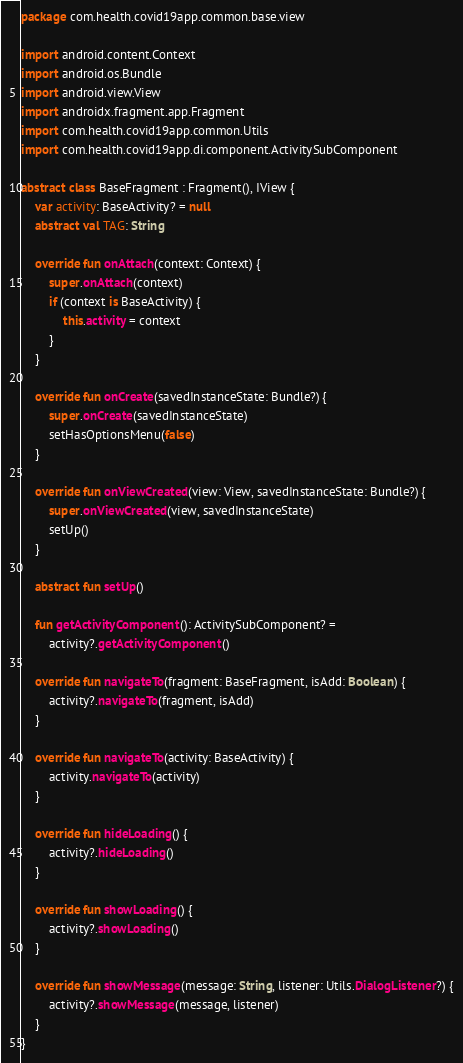Convert code to text. <code><loc_0><loc_0><loc_500><loc_500><_Kotlin_>package com.health.covid19app.common.base.view

import android.content.Context
import android.os.Bundle
import android.view.View
import androidx.fragment.app.Fragment
import com.health.covid19app.common.Utils
import com.health.covid19app.di.component.ActivitySubComponent

abstract class BaseFragment : Fragment(), IView {
    var activity: BaseActivity? = null
    abstract val TAG: String

    override fun onAttach(context: Context) {
        super.onAttach(context)
        if (context is BaseActivity) {
            this.activity = context
        }
    }

    override fun onCreate(savedInstanceState: Bundle?) {
        super.onCreate(savedInstanceState)
        setHasOptionsMenu(false)
    }

    override fun onViewCreated(view: View, savedInstanceState: Bundle?) {
        super.onViewCreated(view, savedInstanceState)
        setUp()
    }

    abstract fun setUp()

    fun getActivityComponent(): ActivitySubComponent? =
        activity?.getActivityComponent()

    override fun navigateTo(fragment: BaseFragment, isAdd: Boolean) {
        activity?.navigateTo(fragment, isAdd)
    }

    override fun navigateTo(activity: BaseActivity) {
        activity.navigateTo(activity)
    }

    override fun hideLoading() {
        activity?.hideLoading()
    }

    override fun showLoading() {
        activity?.showLoading()
    }

    override fun showMessage(message: String, listener: Utils.DialogListener?) {
        activity?.showMessage(message, listener)
    }
}
</code> 